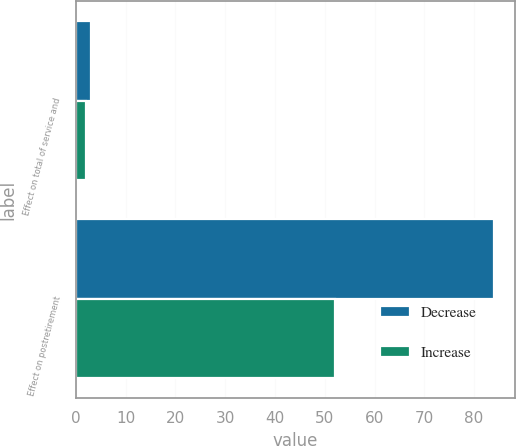<chart> <loc_0><loc_0><loc_500><loc_500><stacked_bar_chart><ecel><fcel>Effect on total of service and<fcel>Effect on postretirement<nl><fcel>Decrease<fcel>3<fcel>84<nl><fcel>Increase<fcel>2<fcel>52<nl></chart> 